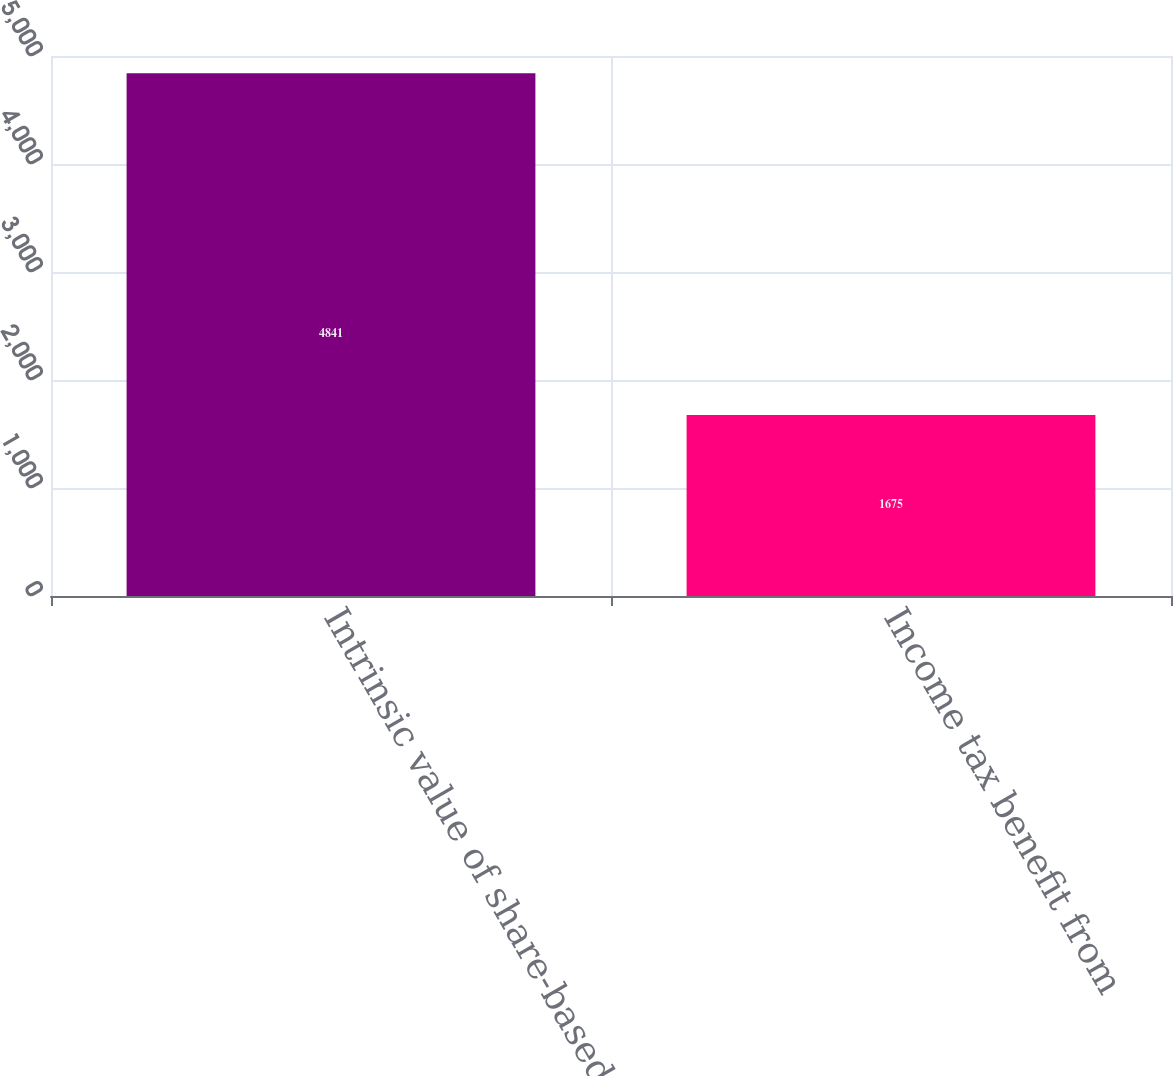Convert chart. <chart><loc_0><loc_0><loc_500><loc_500><bar_chart><fcel>Intrinsic value of share-based<fcel>Income tax benefit from<nl><fcel>4841<fcel>1675<nl></chart> 